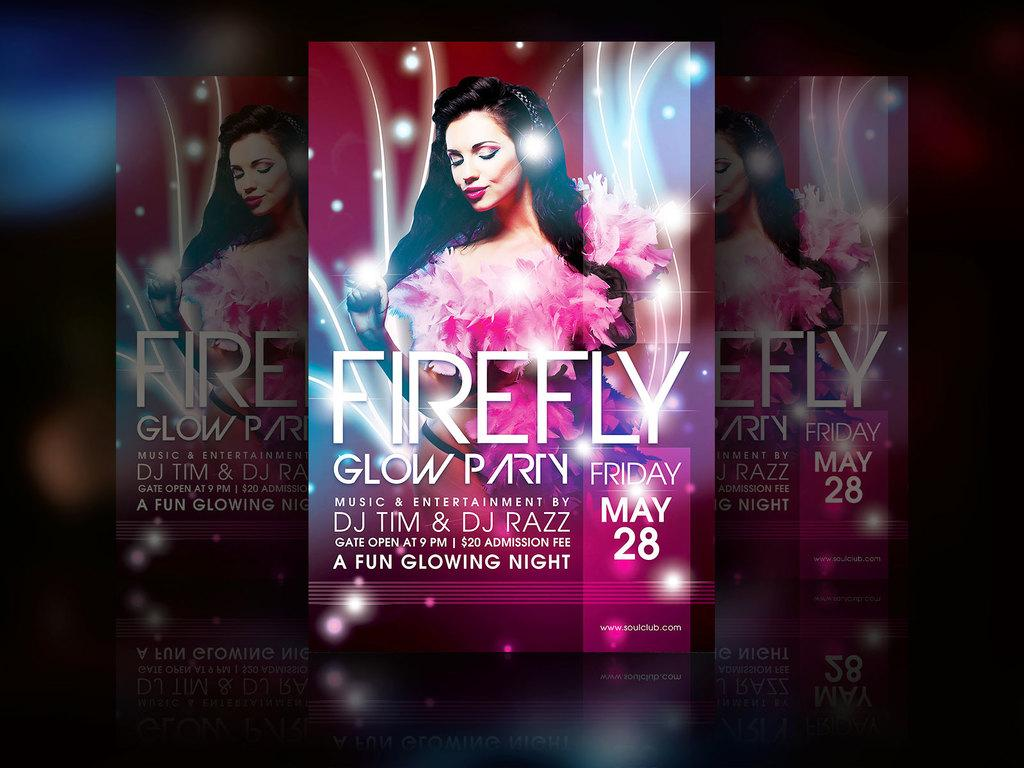<image>
Share a concise interpretation of the image provided. An advertisement for Firefly, glow party on May 28. 